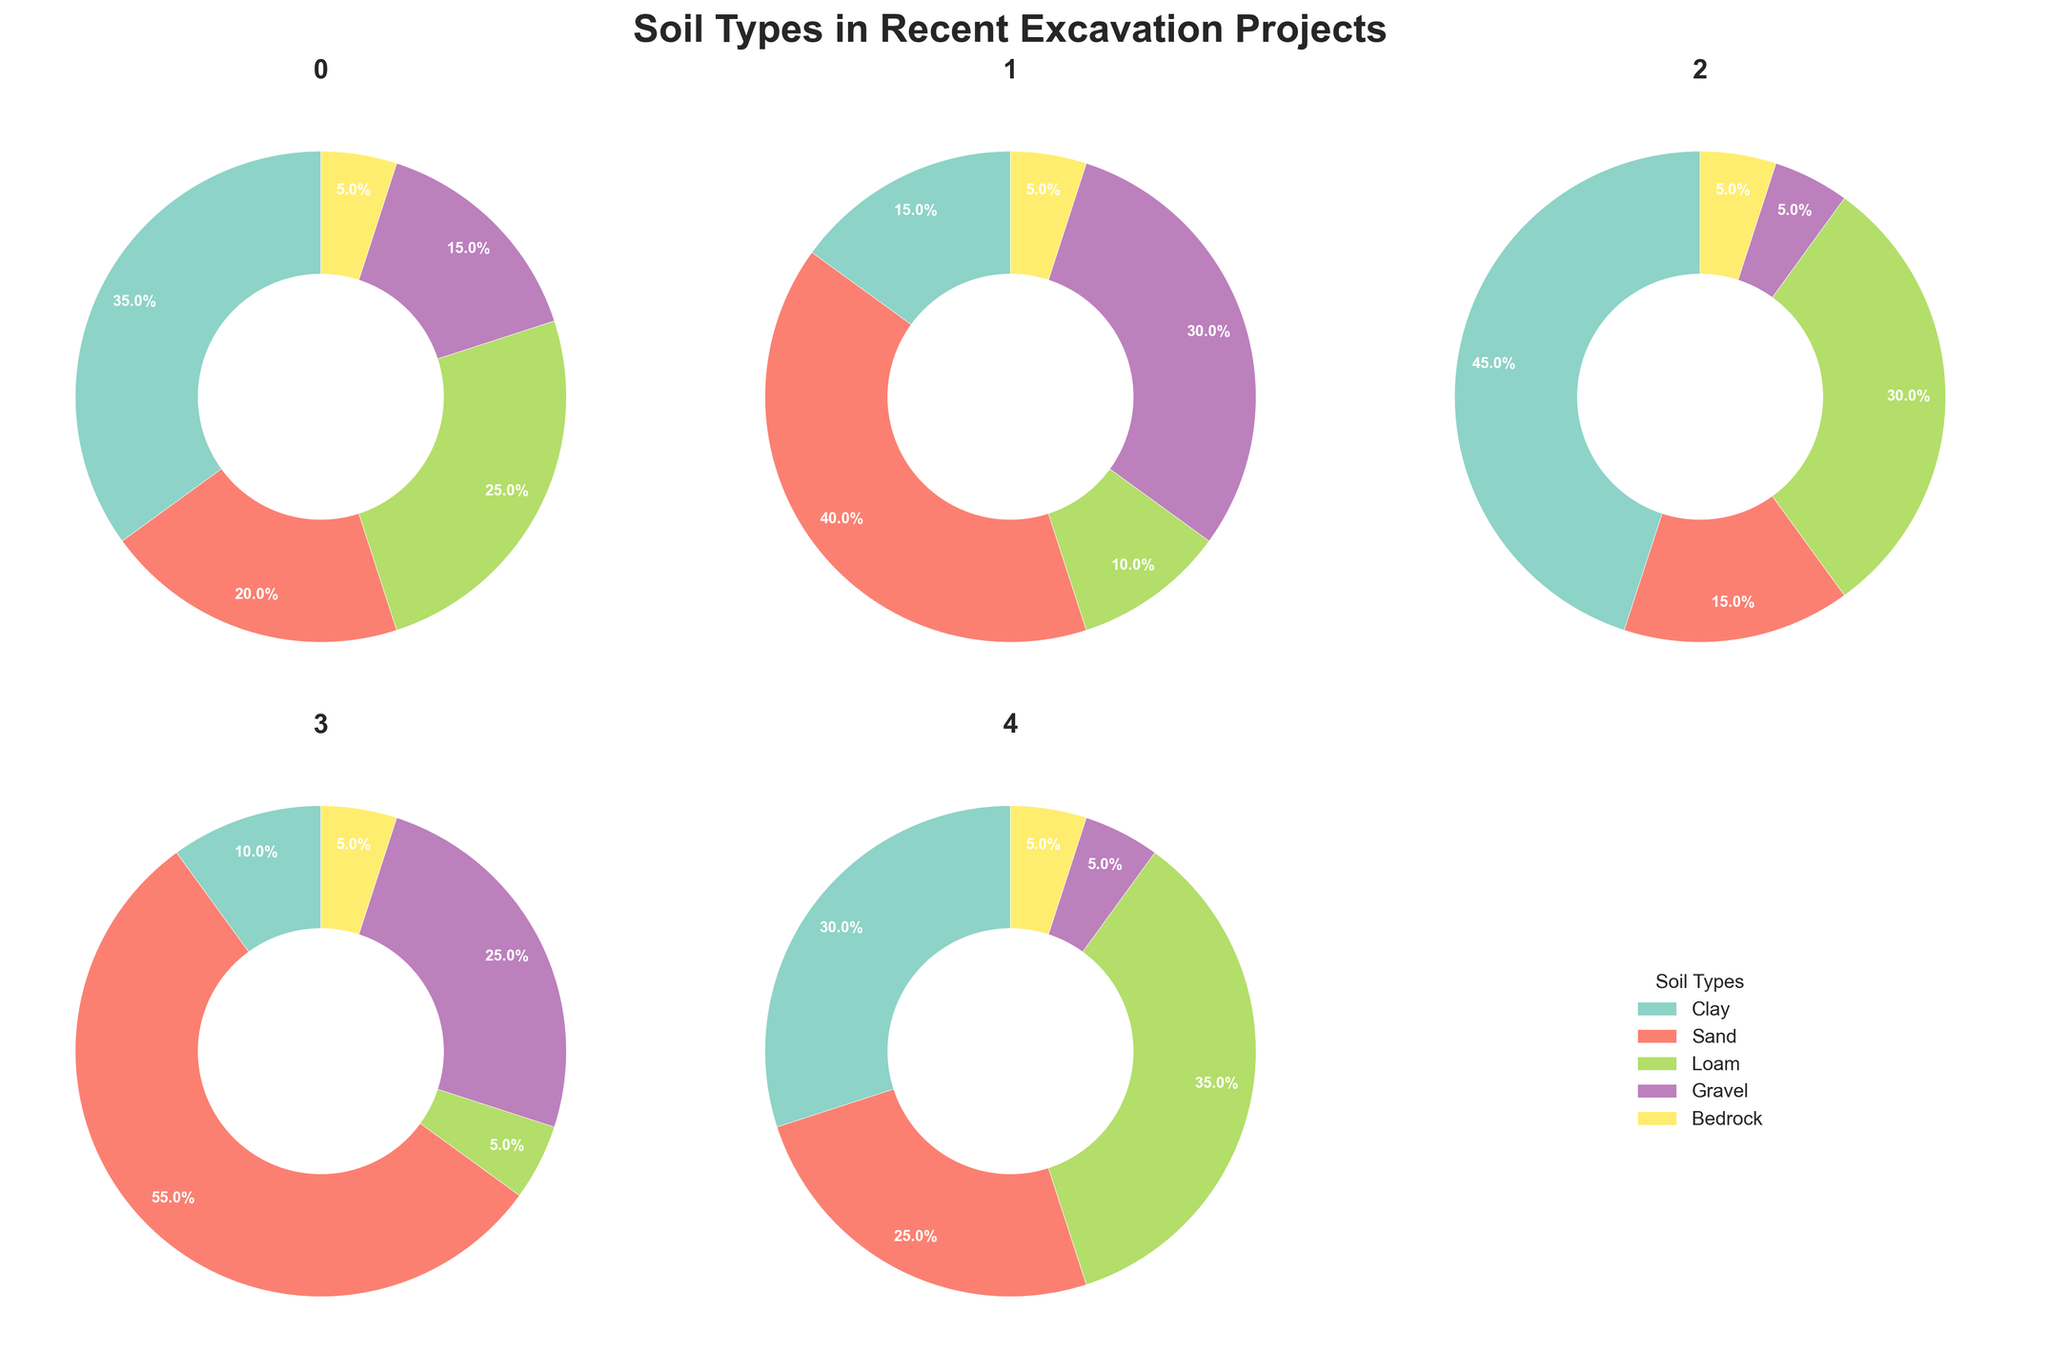How many different soil types are displayed in the pie charts? By looking at the legend and the pie chart segments, we can count the number of distinct soil types.
Answer: 5 Which project has the highest proportion of sand? By comparing the sand segments in each pie chart, we can see that the Waterfront project has the largest sand segment.
Answer: Waterfront What is the aggregate percentage of clay and loam in the Downtown project? According to the Downtown pie chart, clay is 35% and loam is 25%. Adding these gives us 35% + 25% = 60%.
Answer: 60% Which project has an equal percentage of bedrock, and what is that percentage? By comparing the bedrock segments in each pie chart, we observe that Downtown, Industrial Zone, Residential Area, Waterfront, and Suburban Expansion each have 5% bedrock.
Answer: 5% How does the combined percentage of gravel and bedrock in the Suburban Expansion project compare to that in the Industrial Zone project? For the Suburban Expansion project, gravel is 5% and bedrock is 5%, totaling 10%. For the Industrial Zone project, gravel is 30% and bedrock is 5%, totaling 35%. Therefore, the Suburban Expansion (10%) has a smaller combined percentage than the Industrial Zone (35%).
Answer: Suburban Expansion: 10%, Industrial Zone: 35% Which project has the most diverse distribution of soil types, and how can you tell? The most diverse distribution would have the most balanced proportions among the soil types. By looking at the overall balance in the pie charts, the Suburban Expansion project seems most balanced as the percentages of clay (30%), sand (25%), loam (35%), gravel (5%), and bedrock (5%) are relatively close in value.
Answer: Suburban Expansion What is the total percentage of gravel among all projects and how is it calculated? Adding the gravel percentages from each pie chart: Downtown 15% + Industrial Zone 30% + Residential Area 5% + Waterfront 25% + Suburban Expansion 5%, giving a total of 80%.
Answer: 80% Compare the percentage of clay in Downtown to the percentage of loam in the Suburban Expansion area. Which one is higher and by how much? Clay in Downtown is 35%, and loam in the Suburban Expansion is 35%. Both percentages are equal (35%).
Answer: Equal Which project has the lowest percentage of clay, and what is that percentage? By examining the clay segments in each pie chart, Waterfront has the lowest percentage of clay at 10%.
Answer: Waterfront, 10% Is there any project where loam constitutes the highest overall percentage among all soil types? If so, name the project(s). Assessing the pie charts, the Suburban Expansion project has loam at 35%, which is the highest percentage in that project.
Answer: Suburban Expansion 